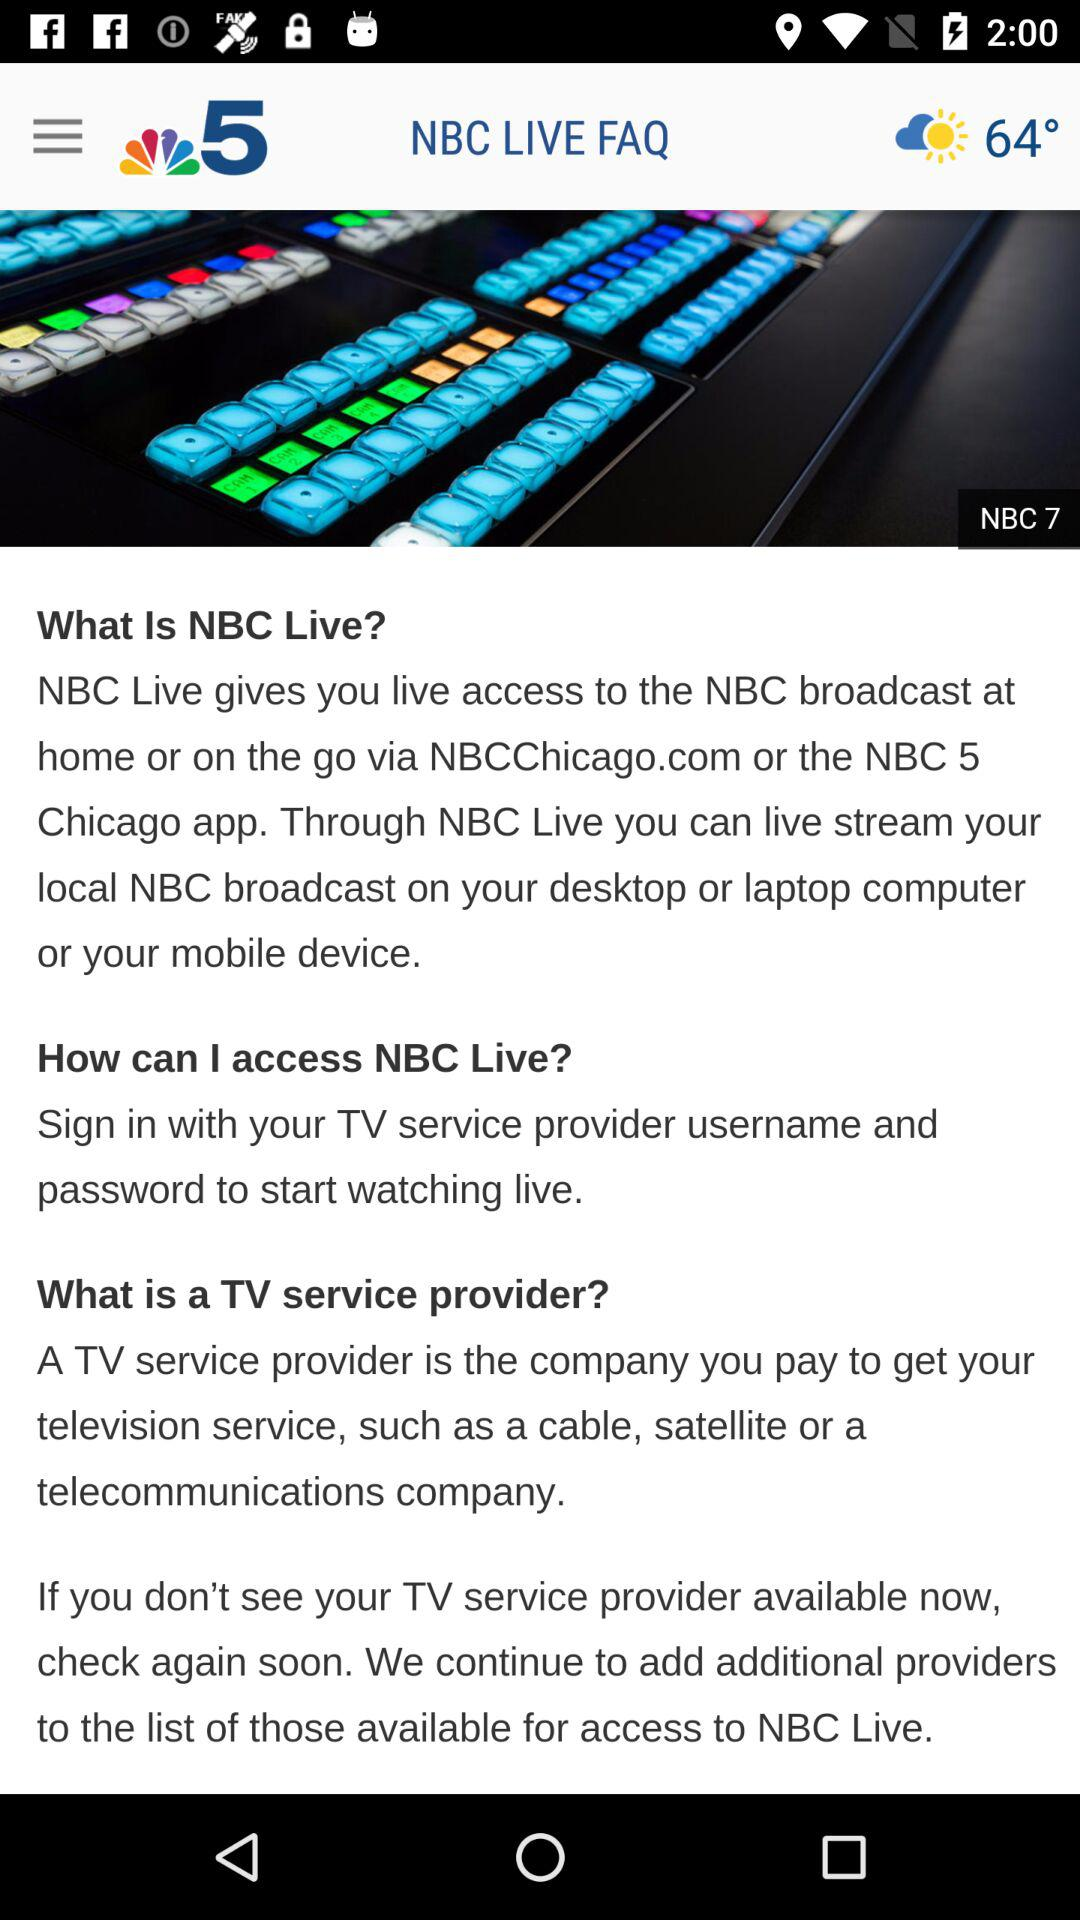Will it be sunny and warm tomorrow too?
When the provided information is insufficient, respond with <no answer>. <no answer> 